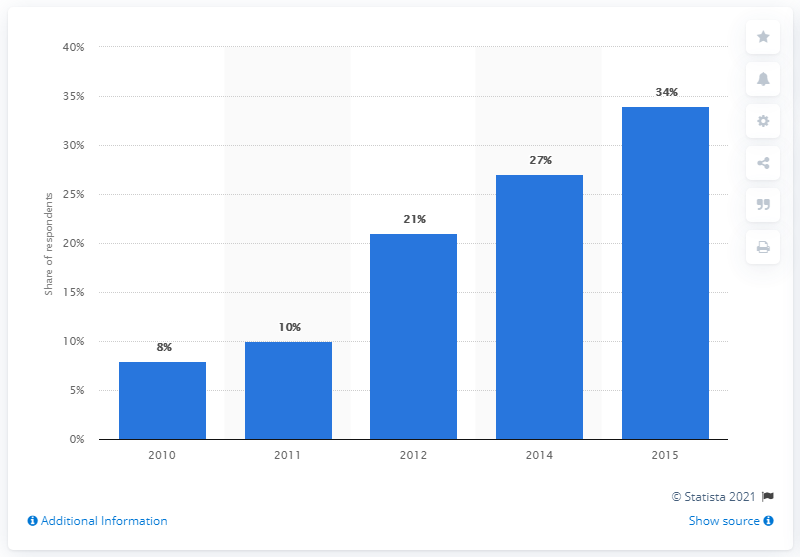List a handful of essential elements in this visual. In 2015, 34% of current account holders used mobile banking at least once a month. 